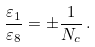Convert formula to latex. <formula><loc_0><loc_0><loc_500><loc_500>\frac { \varepsilon _ { 1 } } { \varepsilon _ { 8 } } = \pm \frac { 1 } { N _ { c } } \, .</formula> 